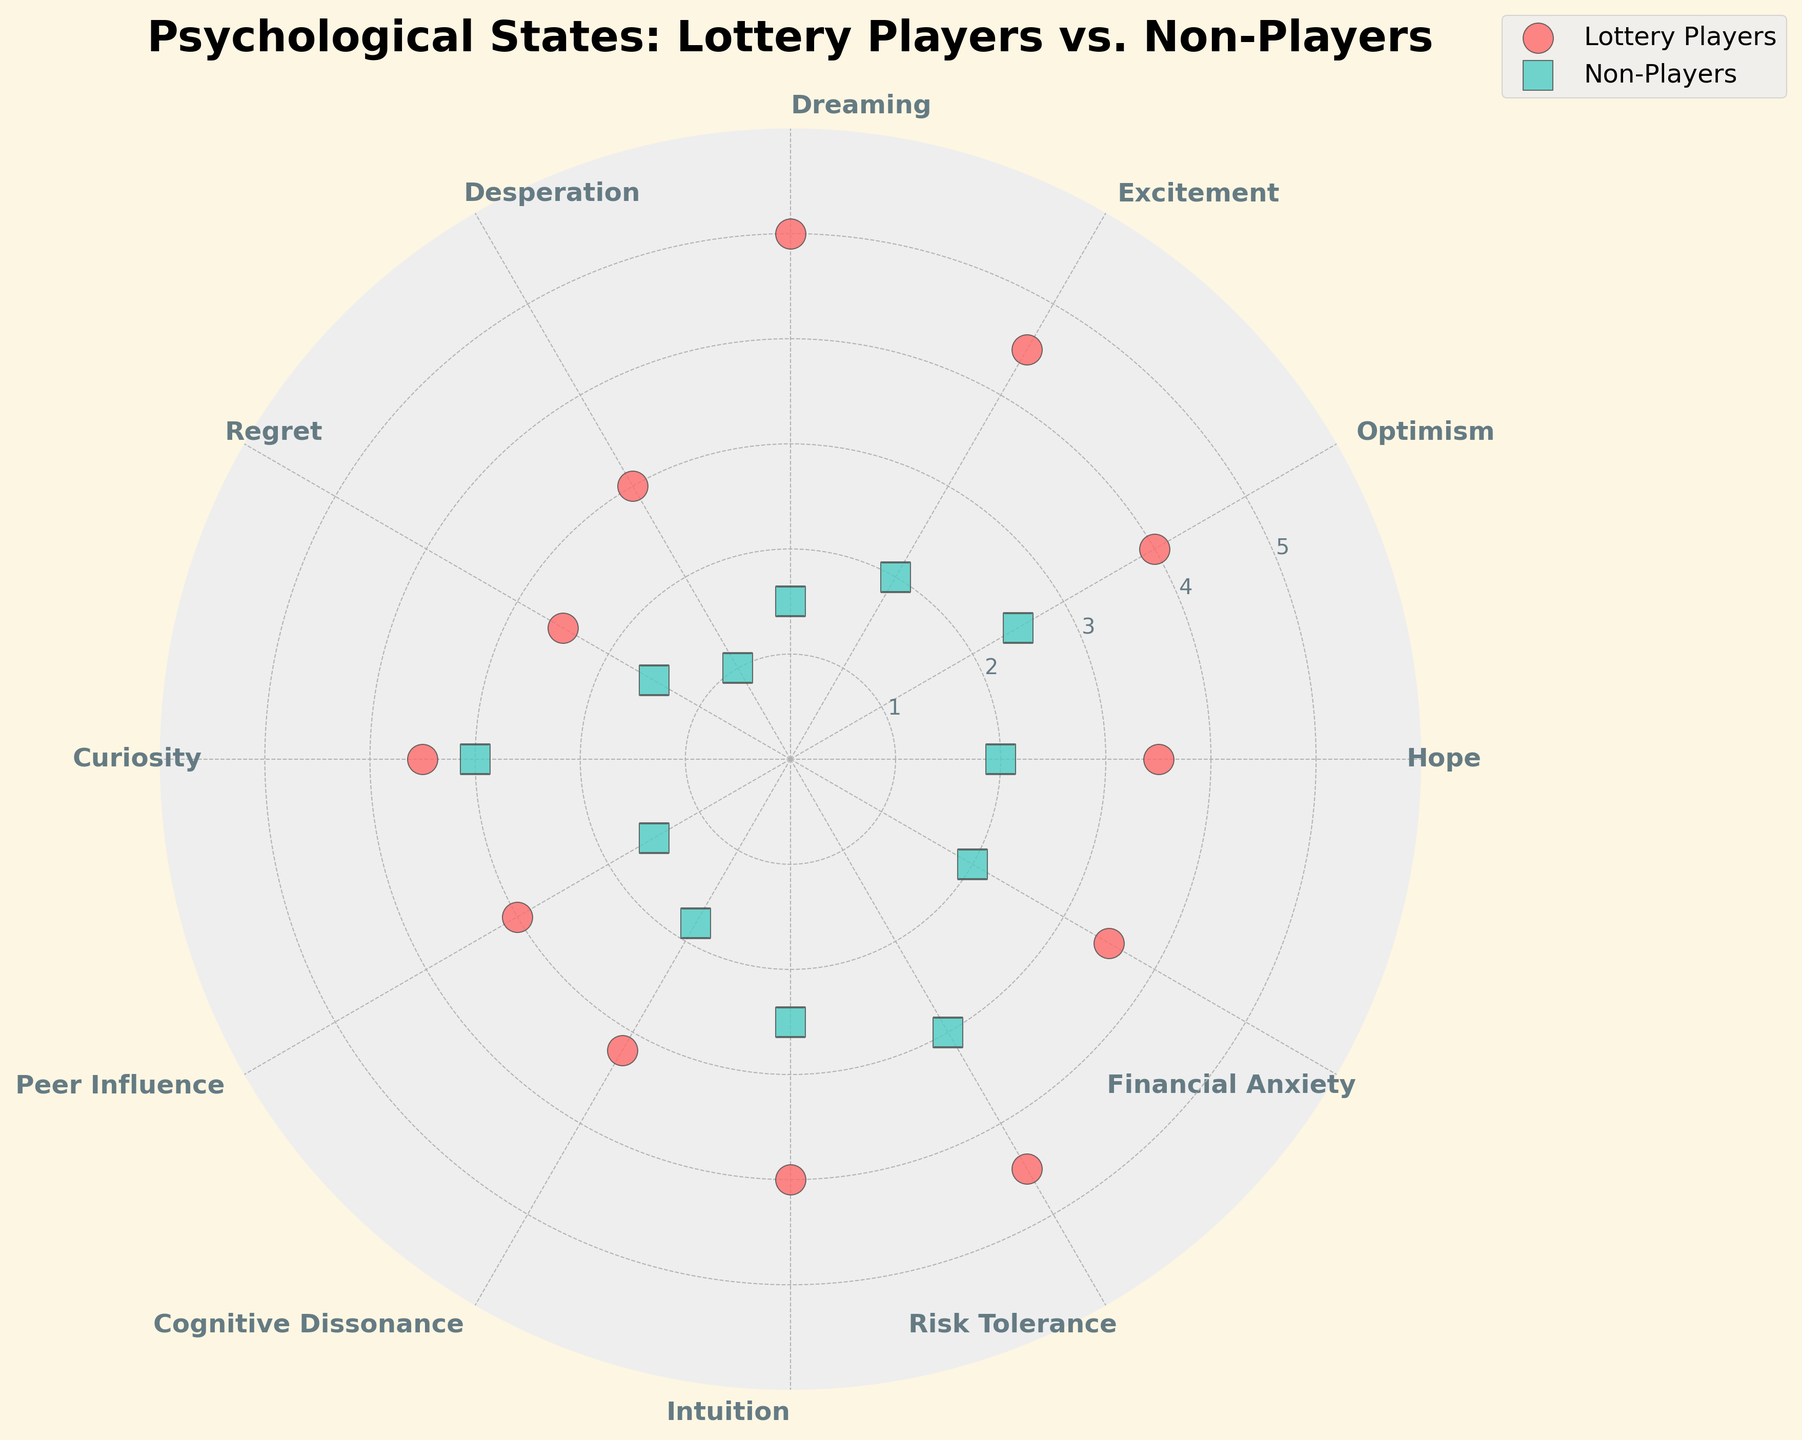Which psychological state has the highest radius among lottery players? Look for the data point with the highest radius in the series for Lottery Players. "Dreaming" has the highest value at a radius of 5.
Answer: Dreaming Which psychological state has the lowest radius among non-players? Look for the smallest radius value in the series for Non-Players. "Desperation" has the lowest radius value at 1.
Answer: Desperation How does the radius value of "Optimism" compare between lottery players and non-players? Compare the radius values for "Optimism" in both series. Lottery players have a radius of 4, while non-players have a radius of 2.5.
Answer: Lottery players have a higher value What is the average radius value of "Excitement" and "Risk Tolerance" for lottery players? Take the radius values for "Excitement" (4.5) and "Risk Tolerance" (4.5) for lottery players and calculate their average: (4.5 + 4.5) / 2 = 4.5.
Answer: 4.5 Which psychological state shows the same radius value for both lottery players and non-players? Find the data point where both series have the same radius value. "Curiosity" has a radius of 3 for both.
Answer: Curiosity By how much does the radius value of "Dreaming" differ between lottery players and non-players? Subtract the radius value of non-players from that of lottery players for "Dreaming": 5 (lottery players) - 1.5 (non-players) = 3.5.
Answer: 3.5 Which psychological state has a radius greater than 4 for lottery players but less than 3 for non-players? Look for a data point where the radius is greater than 4 for one group and less than 3 for the other. "Dreaming" and "Risk Tolerance" match this criterion.
Answer: Dreaming and Risk Tolerance Do lottery players or non-players have a higher average radius value across all psychological states? Calculate the average radius for both series. Sum(radius values for lottery players) / 12 vs. Sum(radius values for non-players) / 12. Lottery players' average: (3.5 + 4 + 4.5 + 5 + 3 + 2.5 + 3.5 + 3 + 3.2 + 4 + 4.5 + 3.5) / 12 = 3.66. Non-players' average: (2 + 2.5 + 2 + 1.5 + 1 + 1.5 + 3 + 1.5 + 1.8 + 2.5 + 3 + 2) / 12 = 2.08.
Answer: Lottery players have a higher average 